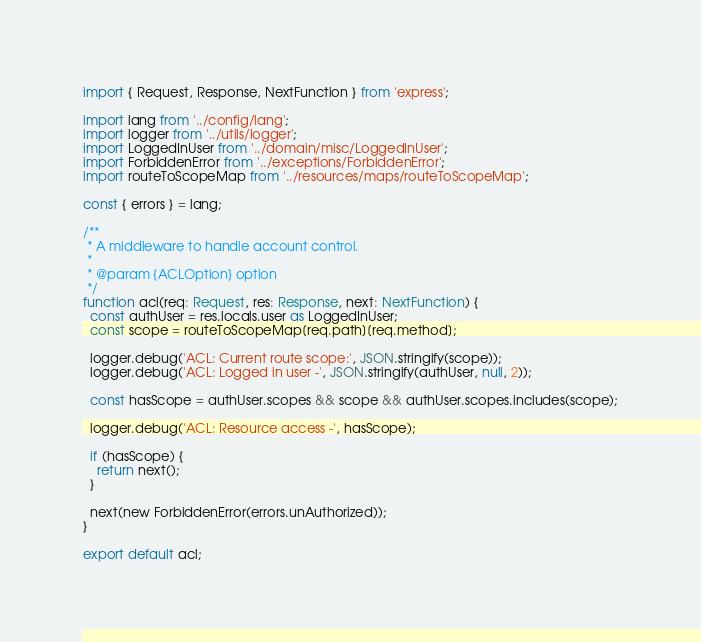<code> <loc_0><loc_0><loc_500><loc_500><_TypeScript_>import { Request, Response, NextFunction } from 'express';

import lang from '../config/lang';
import logger from '../utils/logger';
import LoggedInUser from '../domain/misc/LoggedInUser';
import ForbiddenError from '../exceptions/ForbiddenError';
import routeToScopeMap from '../resources/maps/routeToScopeMap';

const { errors } = lang;

/**
 * A middleware to handle account control.
 *
 * @param {ACLOption} option
 */
function acl(req: Request, res: Response, next: NextFunction) {
  const authUser = res.locals.user as LoggedInUser;
  const scope = routeToScopeMap[req.path][req.method];

  logger.debug('ACL: Current route scope:', JSON.stringify(scope));
  logger.debug('ACL: Logged in user -', JSON.stringify(authUser, null, 2));

  const hasScope = authUser.scopes && scope && authUser.scopes.includes(scope);

  logger.debug('ACL: Resource access -', hasScope);

  if (hasScope) {
    return next();
  }

  next(new ForbiddenError(errors.unAuthorized));
}

export default acl;
</code> 